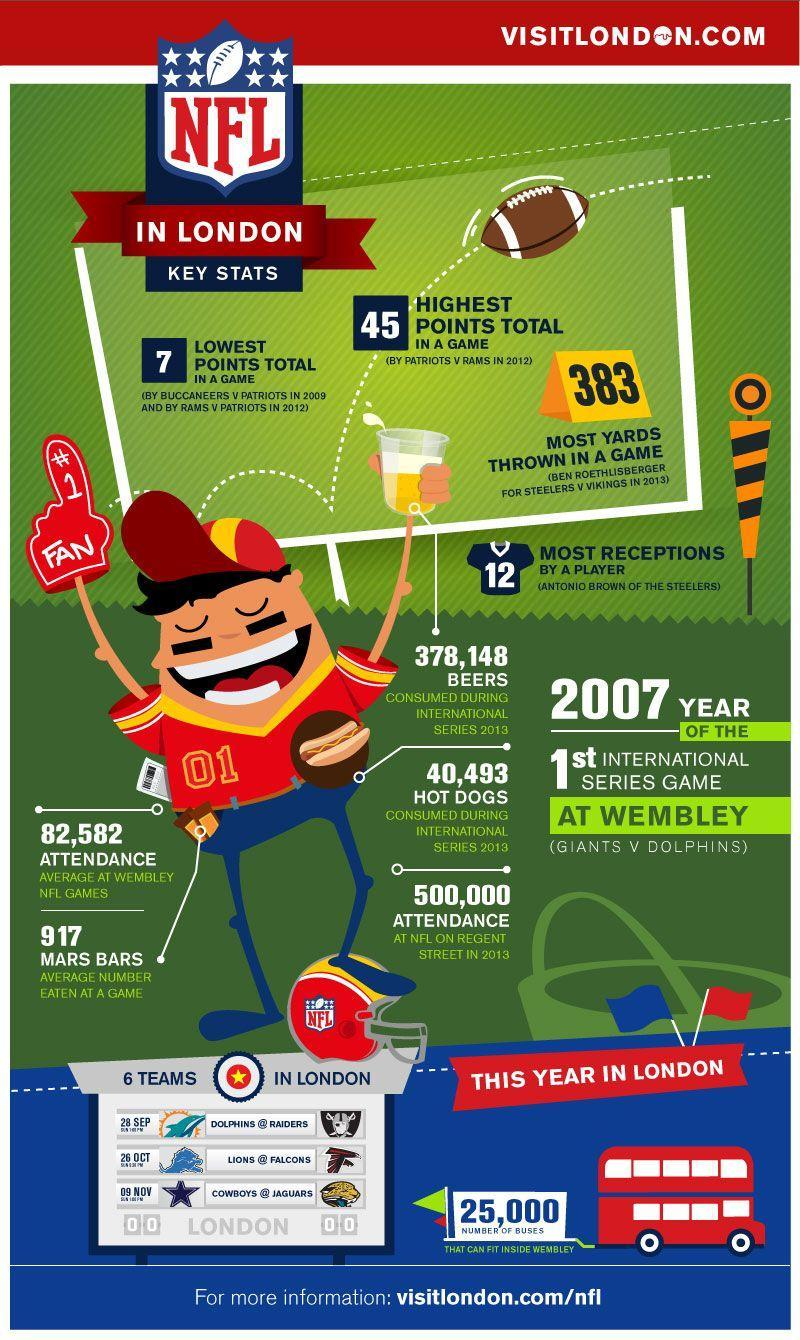What is the most number of receptions made by a player in the NFL games in London?
Answer the question with a short phrase. 12 When did the NFL start playing international games? 2007 How many people attended the NFL on regent street in 2013? 500,000 Who has thrown the most yards in the NFL games in London in 2013? BEN ROETHLISBERGER 